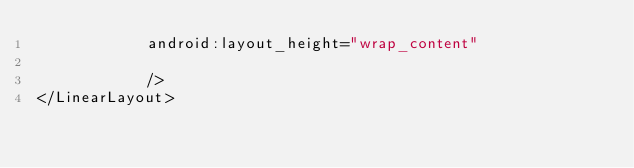<code> <loc_0><loc_0><loc_500><loc_500><_XML_>            android:layout_height="wrap_content"

            />
</LinearLayout>

</code> 